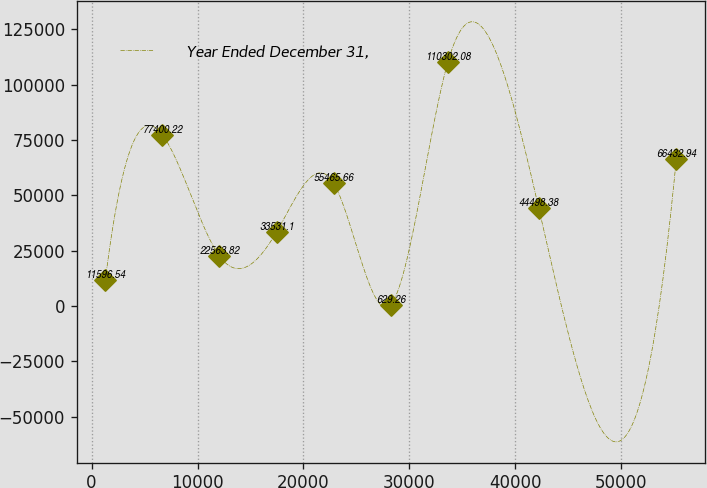Convert chart. <chart><loc_0><loc_0><loc_500><loc_500><line_chart><ecel><fcel>Year Ended December 31,<nl><fcel>1291.39<fcel>11596.5<nl><fcel>6682.37<fcel>77400.2<nl><fcel>12073.4<fcel>22563.8<nl><fcel>17464.3<fcel>33531.1<nl><fcel>22855.3<fcel>55465.7<nl><fcel>28246.3<fcel>629.26<nl><fcel>33637.3<fcel>110302<nl><fcel>42203.3<fcel>44498.4<nl><fcel>55201.1<fcel>66432.9<nl></chart> 